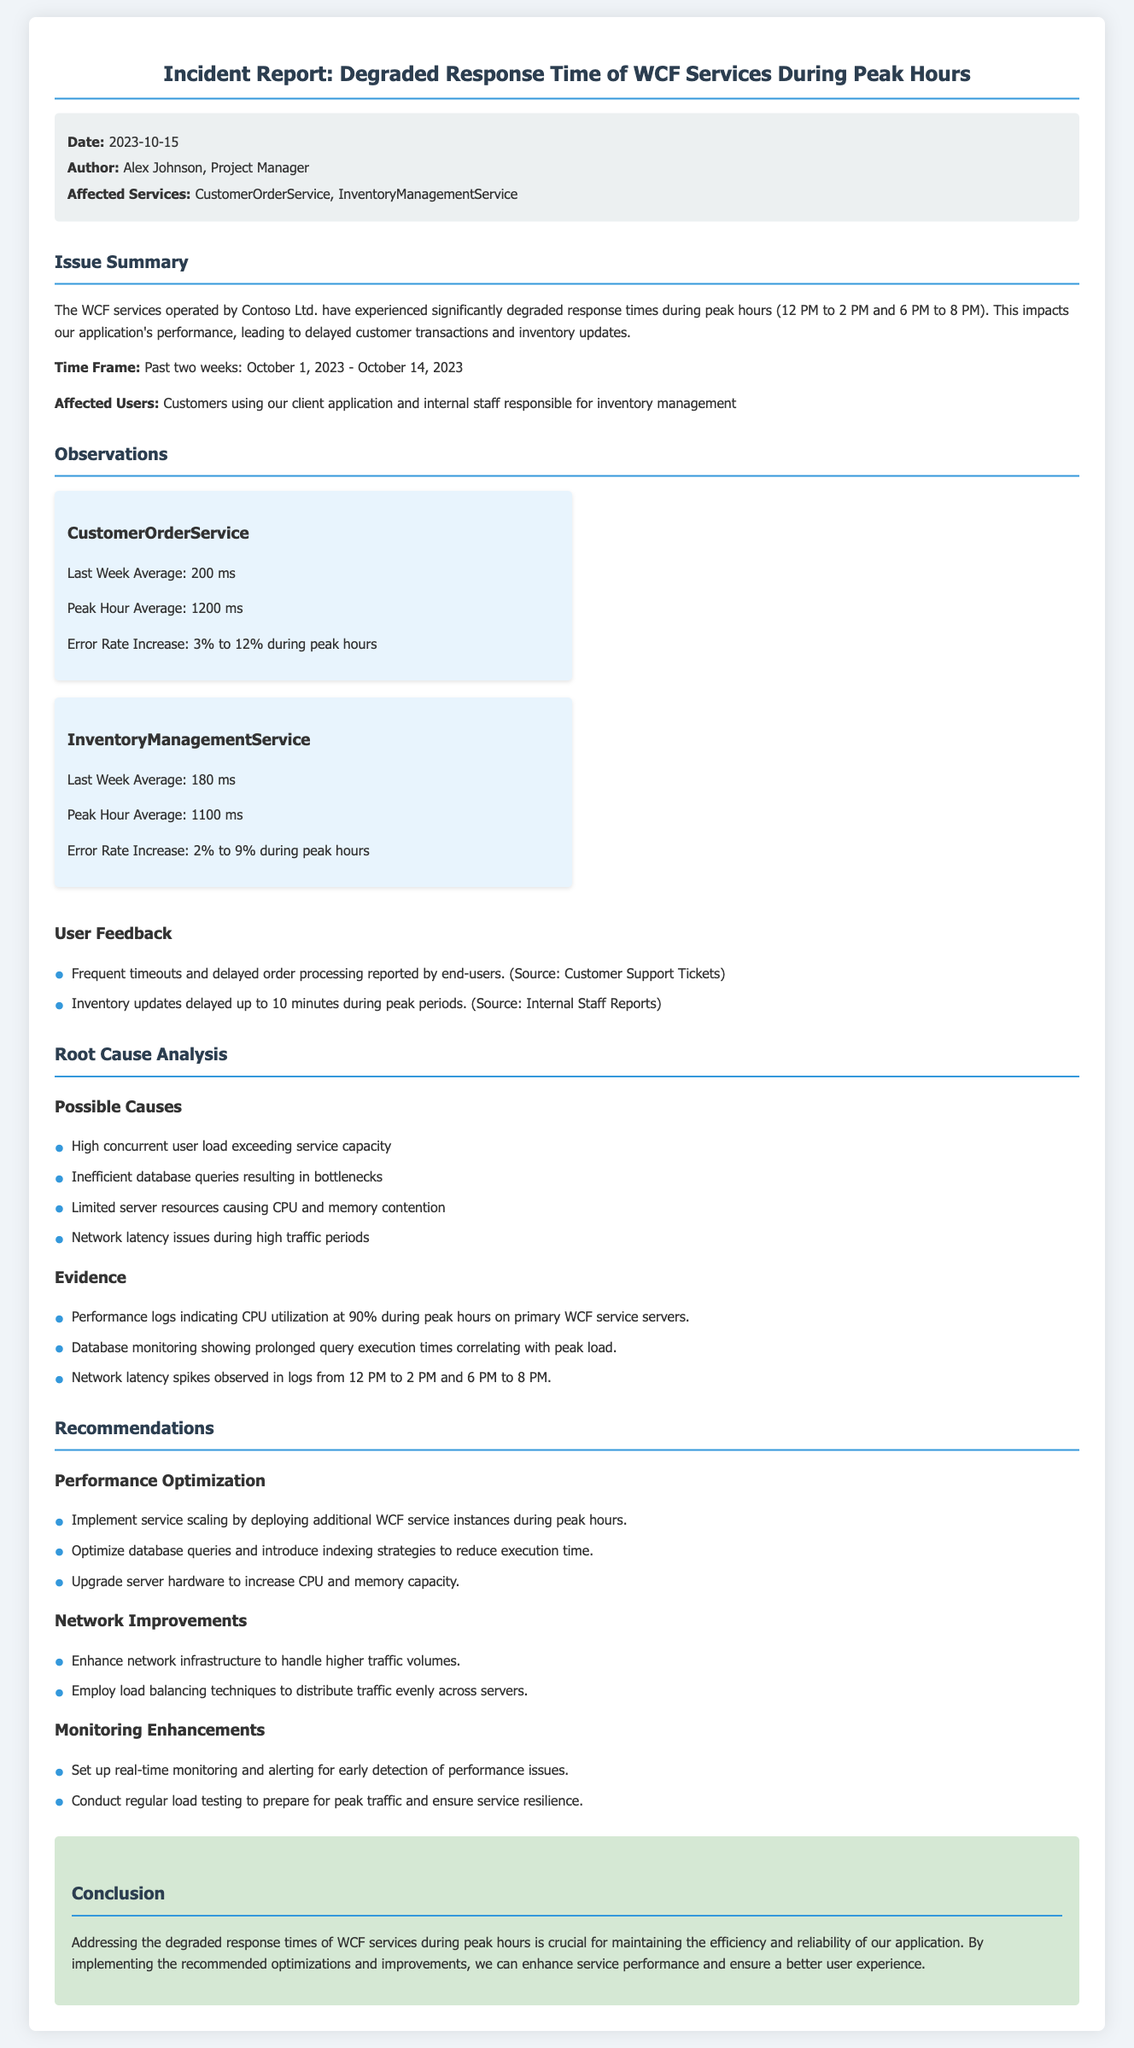What is the date of the incident report? The date of the incident report is stated in the meta-info section.
Answer: 2023-10-15 Who authored the incident report? The author's name is indicated in the meta-info section of the document.
Answer: Alex Johnson What was the average response time for the CustomerOrderService during peak hours? This information is provided under the observations for the CustomerOrderService.
Answer: 1200 ms What percentage did the error rate increase to for the InventoryManagementService during peak hours? The document specifies the error rate increase in the observations section for the InventoryManagementService.
Answer: 9% What were the peak hours mentioned in the report? The report states the peak hours in the issue summary section.
Answer: 12 PM to 2 PM and 6 PM to 8 PM What is one of the recommended performance optimizations? The recommendations section suggests specific improvements for service performance.
Answer: Implement service scaling What was the CPU utilization percentage during peak hours? This percentage is indicated in the evidence provided in the root cause analysis section.
Answer: 90% What type of monitoring is recommended for early detection of performance issues? The document outlines various monitoring enhancements in its recommendations.
Answer: Real-time monitoring What impacted the performance of the WCF services during peak hours? The issue summary discusses the effects of degraded response times on application performance.
Answer: Delayed customer transactions 